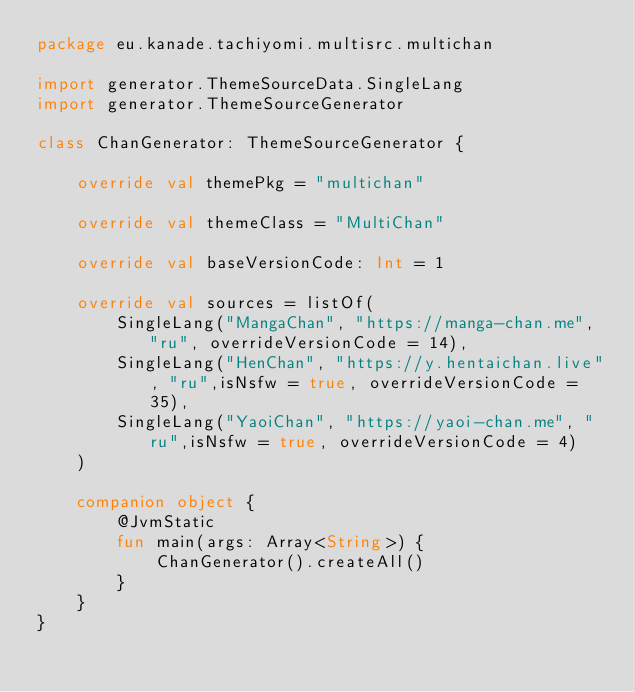Convert code to text. <code><loc_0><loc_0><loc_500><loc_500><_Kotlin_>package eu.kanade.tachiyomi.multisrc.multichan

import generator.ThemeSourceData.SingleLang
import generator.ThemeSourceGenerator

class ChanGenerator: ThemeSourceGenerator {

    override val themePkg = "multichan"

    override val themeClass = "MultiChan"

    override val baseVersionCode: Int = 1

    override val sources = listOf(
        SingleLang("MangaChan", "https://manga-chan.me", "ru", overrideVersionCode = 14),
        SingleLang("HenChan", "https://y.hentaichan.live", "ru",isNsfw = true, overrideVersionCode = 35),
        SingleLang("YaoiChan", "https://yaoi-chan.me", "ru",isNsfw = true, overrideVersionCode = 4)
    )

    companion object {
        @JvmStatic
        fun main(args: Array<String>) {
            ChanGenerator().createAll()
        }
    }
}
</code> 